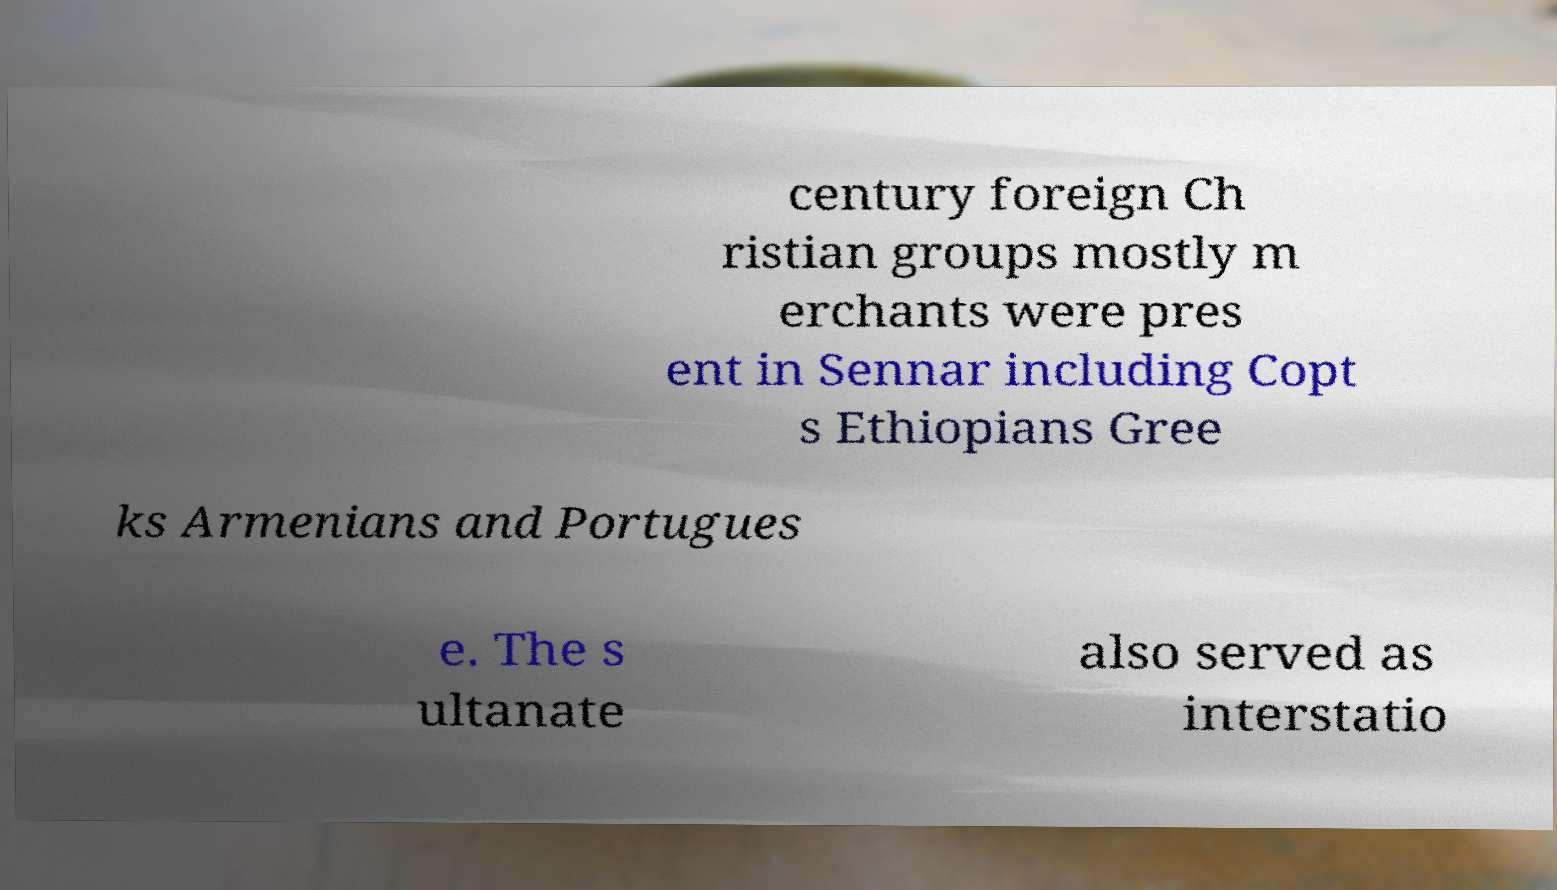Could you extract and type out the text from this image? century foreign Ch ristian groups mostly m erchants were pres ent in Sennar including Copt s Ethiopians Gree ks Armenians and Portugues e. The s ultanate also served as interstatio 